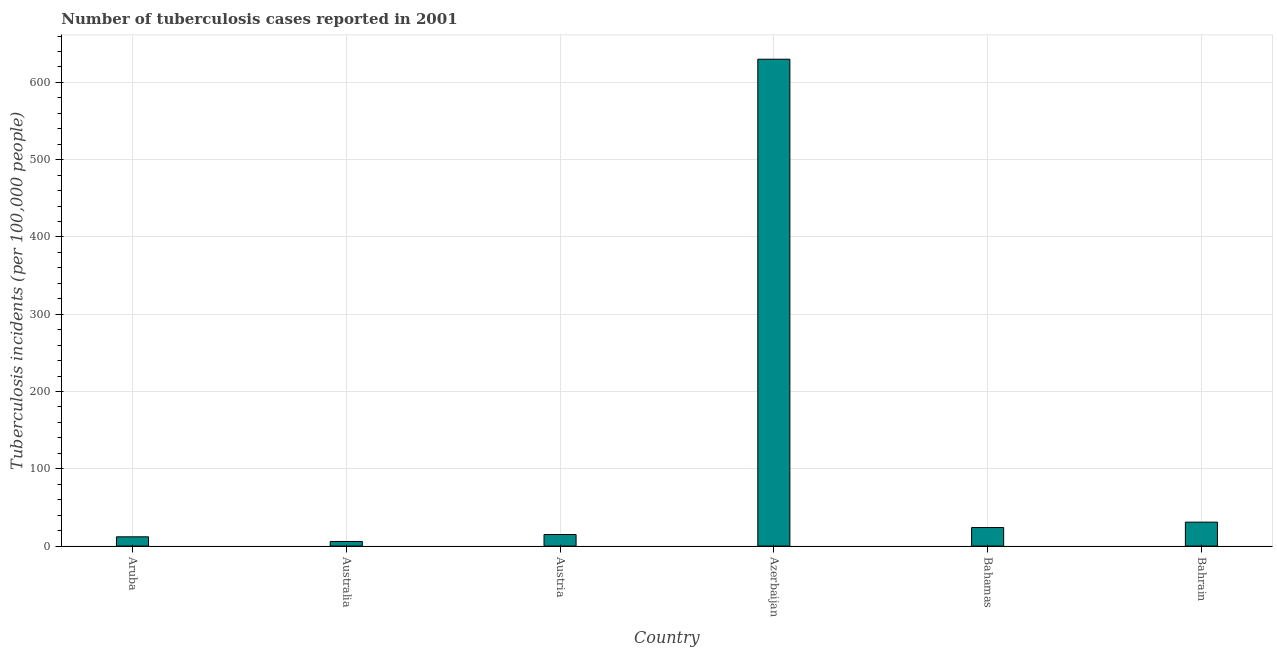Does the graph contain any zero values?
Your response must be concise. No. Does the graph contain grids?
Give a very brief answer. Yes. What is the title of the graph?
Give a very brief answer. Number of tuberculosis cases reported in 2001. What is the label or title of the Y-axis?
Keep it short and to the point. Tuberculosis incidents (per 100,0 people). What is the number of tuberculosis incidents in Aruba?
Your answer should be compact. 12. Across all countries, what is the maximum number of tuberculosis incidents?
Your response must be concise. 630. Across all countries, what is the minimum number of tuberculosis incidents?
Your answer should be very brief. 6. In which country was the number of tuberculosis incidents maximum?
Keep it short and to the point. Azerbaijan. In which country was the number of tuberculosis incidents minimum?
Provide a succinct answer. Australia. What is the sum of the number of tuberculosis incidents?
Your answer should be very brief. 718. What is the difference between the number of tuberculosis incidents in Aruba and Bahamas?
Offer a terse response. -12. What is the average number of tuberculosis incidents per country?
Make the answer very short. 119.67. What is the median number of tuberculosis incidents?
Give a very brief answer. 19.5. In how many countries, is the number of tuberculosis incidents greater than 560 ?
Make the answer very short. 1. What is the ratio of the number of tuberculosis incidents in Aruba to that in Bahrain?
Keep it short and to the point. 0.39. Is the number of tuberculosis incidents in Aruba less than that in Austria?
Offer a terse response. Yes. What is the difference between the highest and the second highest number of tuberculosis incidents?
Your response must be concise. 599. What is the difference between the highest and the lowest number of tuberculosis incidents?
Offer a terse response. 624. Are all the bars in the graph horizontal?
Make the answer very short. No. How many countries are there in the graph?
Provide a short and direct response. 6. Are the values on the major ticks of Y-axis written in scientific E-notation?
Your response must be concise. No. What is the Tuberculosis incidents (per 100,000 people) in Azerbaijan?
Your response must be concise. 630. What is the Tuberculosis incidents (per 100,000 people) of Bahrain?
Offer a terse response. 31. What is the difference between the Tuberculosis incidents (per 100,000 people) in Aruba and Austria?
Offer a very short reply. -3. What is the difference between the Tuberculosis incidents (per 100,000 people) in Aruba and Azerbaijan?
Make the answer very short. -618. What is the difference between the Tuberculosis incidents (per 100,000 people) in Australia and Azerbaijan?
Keep it short and to the point. -624. What is the difference between the Tuberculosis incidents (per 100,000 people) in Austria and Azerbaijan?
Give a very brief answer. -615. What is the difference between the Tuberculosis incidents (per 100,000 people) in Azerbaijan and Bahamas?
Your answer should be compact. 606. What is the difference between the Tuberculosis incidents (per 100,000 people) in Azerbaijan and Bahrain?
Make the answer very short. 599. What is the difference between the Tuberculosis incidents (per 100,000 people) in Bahamas and Bahrain?
Ensure brevity in your answer.  -7. What is the ratio of the Tuberculosis incidents (per 100,000 people) in Aruba to that in Austria?
Offer a very short reply. 0.8. What is the ratio of the Tuberculosis incidents (per 100,000 people) in Aruba to that in Azerbaijan?
Your answer should be compact. 0.02. What is the ratio of the Tuberculosis incidents (per 100,000 people) in Aruba to that in Bahamas?
Your response must be concise. 0.5. What is the ratio of the Tuberculosis incidents (per 100,000 people) in Aruba to that in Bahrain?
Your answer should be compact. 0.39. What is the ratio of the Tuberculosis incidents (per 100,000 people) in Australia to that in Austria?
Ensure brevity in your answer.  0.4. What is the ratio of the Tuberculosis incidents (per 100,000 people) in Australia to that in Azerbaijan?
Give a very brief answer. 0.01. What is the ratio of the Tuberculosis incidents (per 100,000 people) in Australia to that in Bahamas?
Ensure brevity in your answer.  0.25. What is the ratio of the Tuberculosis incidents (per 100,000 people) in Australia to that in Bahrain?
Ensure brevity in your answer.  0.19. What is the ratio of the Tuberculosis incidents (per 100,000 people) in Austria to that in Azerbaijan?
Provide a succinct answer. 0.02. What is the ratio of the Tuberculosis incidents (per 100,000 people) in Austria to that in Bahrain?
Offer a very short reply. 0.48. What is the ratio of the Tuberculosis incidents (per 100,000 people) in Azerbaijan to that in Bahamas?
Make the answer very short. 26.25. What is the ratio of the Tuberculosis incidents (per 100,000 people) in Azerbaijan to that in Bahrain?
Make the answer very short. 20.32. What is the ratio of the Tuberculosis incidents (per 100,000 people) in Bahamas to that in Bahrain?
Ensure brevity in your answer.  0.77. 